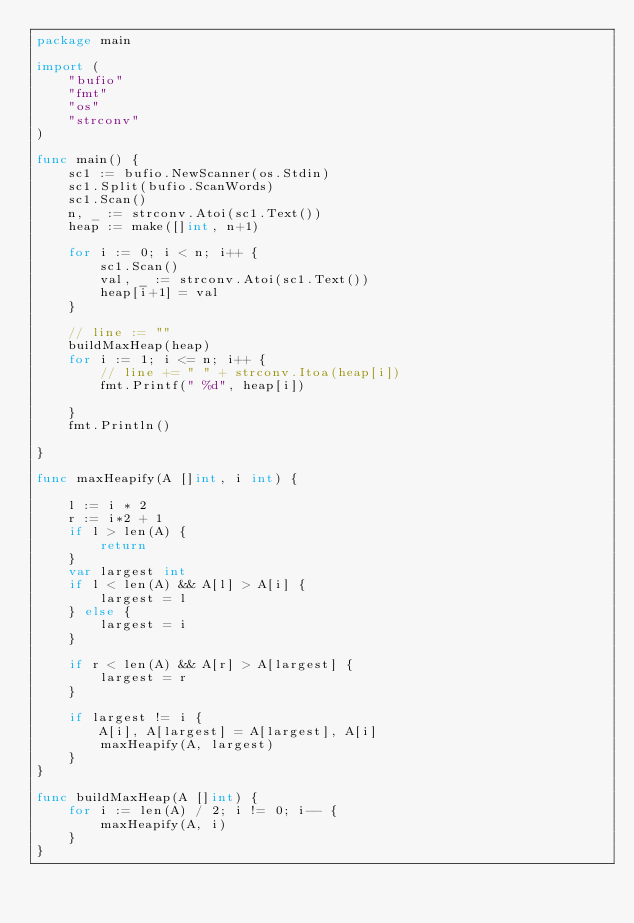<code> <loc_0><loc_0><loc_500><loc_500><_Go_>package main

import (
	"bufio"
	"fmt"
	"os"
	"strconv"
)

func main() {
	sc1 := bufio.NewScanner(os.Stdin)
	sc1.Split(bufio.ScanWords)
	sc1.Scan()
	n, _ := strconv.Atoi(sc1.Text())
	heap := make([]int, n+1)

	for i := 0; i < n; i++ {
		sc1.Scan()
		val, _ := strconv.Atoi(sc1.Text())
		heap[i+1] = val
	}

	// line := ""
	buildMaxHeap(heap)
	for i := 1; i <= n; i++ {
		// line += " " + strconv.Itoa(heap[i])
		fmt.Printf(" %d", heap[i])

	}
	fmt.Println()

}

func maxHeapify(A []int, i int) {

	l := i * 2
	r := i*2 + 1
	if l > len(A) {
		return
	}
	var largest int
	if l < len(A) && A[l] > A[i] {
		largest = l
	} else {
		largest = i
	}

	if r < len(A) && A[r] > A[largest] {
		largest = r
	}

	if largest != i {
		A[i], A[largest] = A[largest], A[i]
		maxHeapify(A, largest)
	}
}

func buildMaxHeap(A []int) {
	for i := len(A) / 2; i != 0; i-- {
		maxHeapify(A, i)
	}
}

</code> 